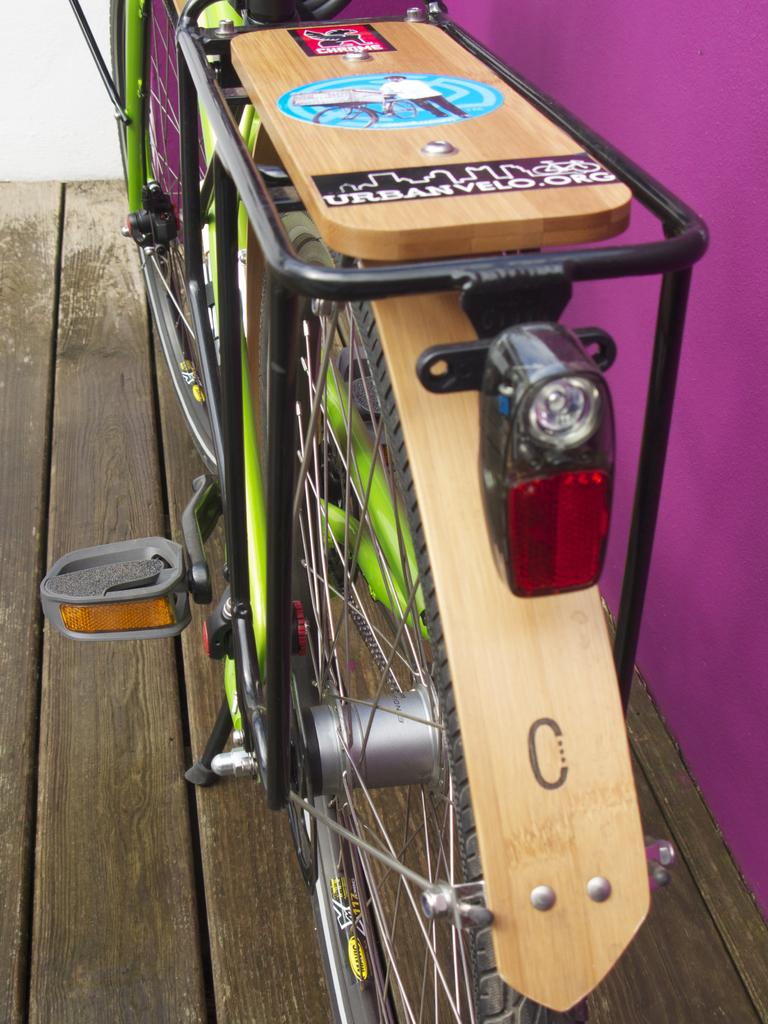What is the main object in the image? There is a bicycle in the image. How is the bicycle positioned in the image? The bicycle is placed on a wooden plank. What can be seen on the right side of the image? There is a wall on the right side of the image. What color is the wall in the image? The wall is painted with pink color. What advice is given on the page next to the bicycle in the image? There is no page or any text present in the image; it only features a bicycle on a wooden plank and a pink wall. 